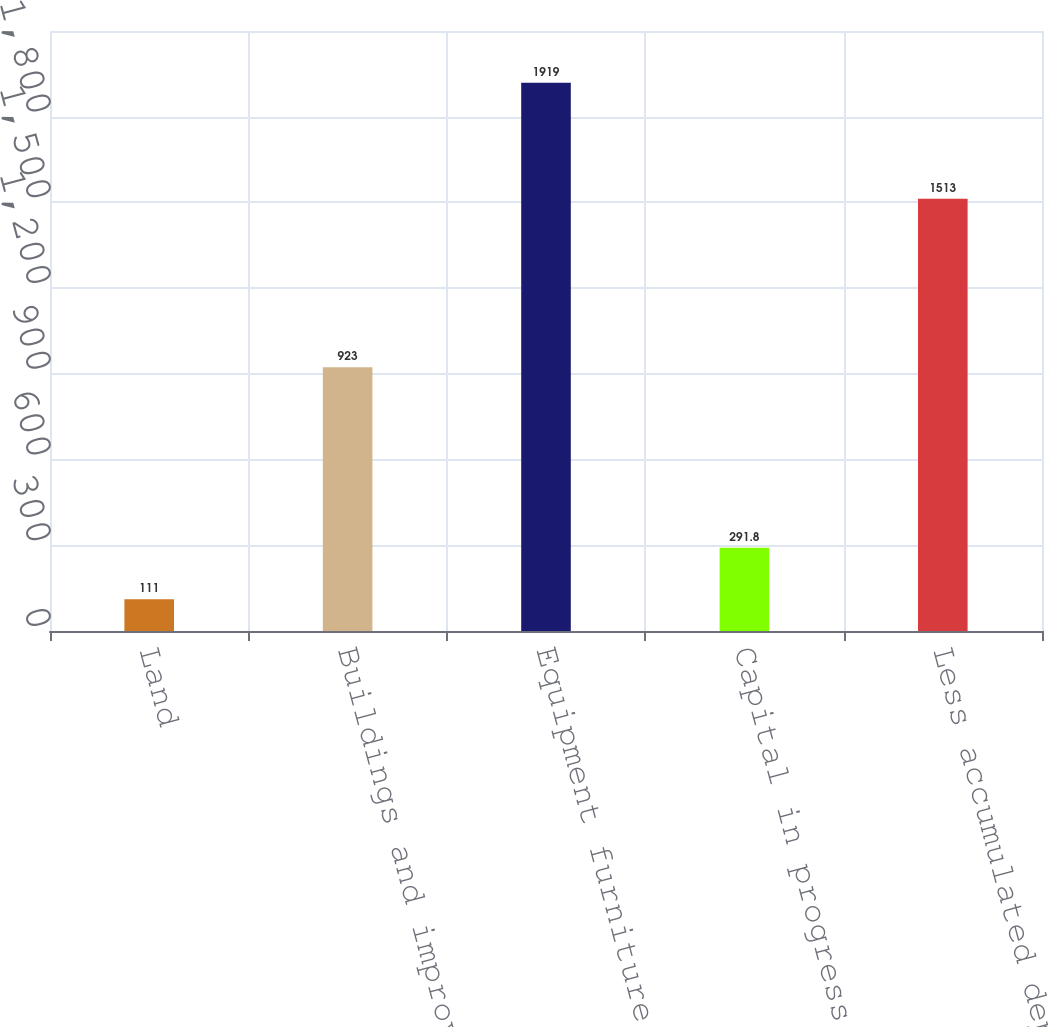<chart> <loc_0><loc_0><loc_500><loc_500><bar_chart><fcel>Land<fcel>Buildings and improvements<fcel>Equipment furniture and<fcel>Capital in progress<fcel>Less accumulated depreciation<nl><fcel>111<fcel>923<fcel>1919<fcel>291.8<fcel>1513<nl></chart> 